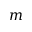Convert formula to latex. <formula><loc_0><loc_0><loc_500><loc_500>m</formula> 